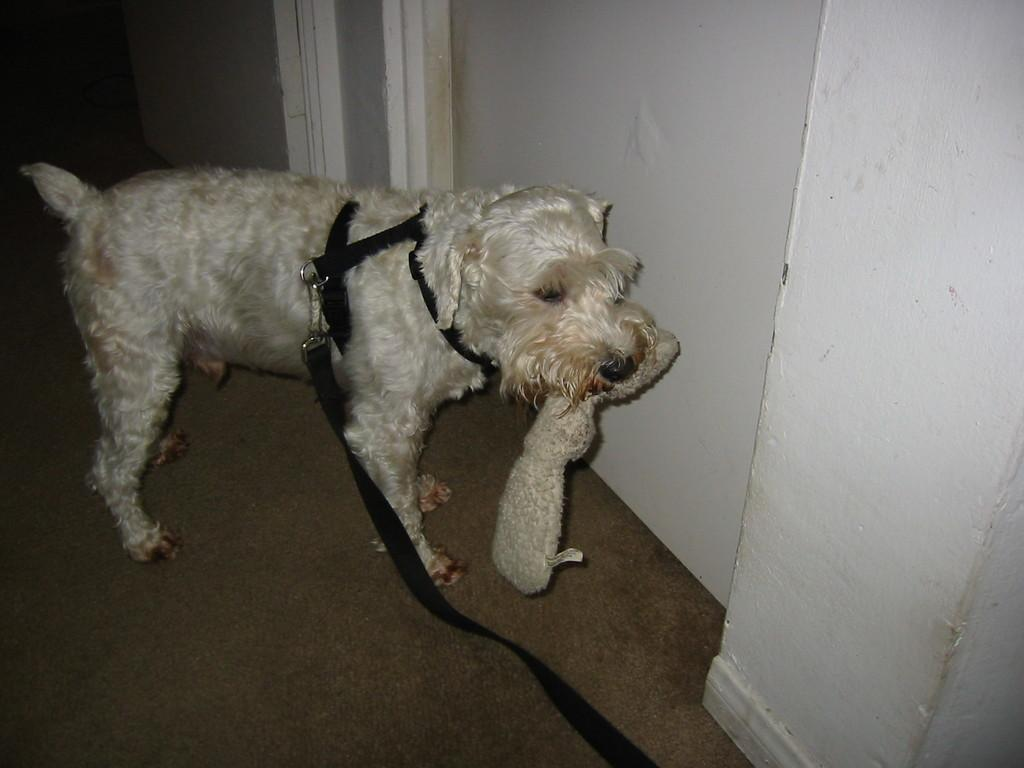What type of animal is in the picture? There is a white dog in the picture. What is around the dog's neck? The dog has a black belt around its neck. What is the dog holding in its mouth? The dog is holding something in its mouth. Where is the dog standing? The dog is standing on the floor. What can be seen in the background of the picture? There is a white wall in the background. What is the dog's opinion on the current tax policies? There is no information in the image to determine the dog's opinion on tax policies. 